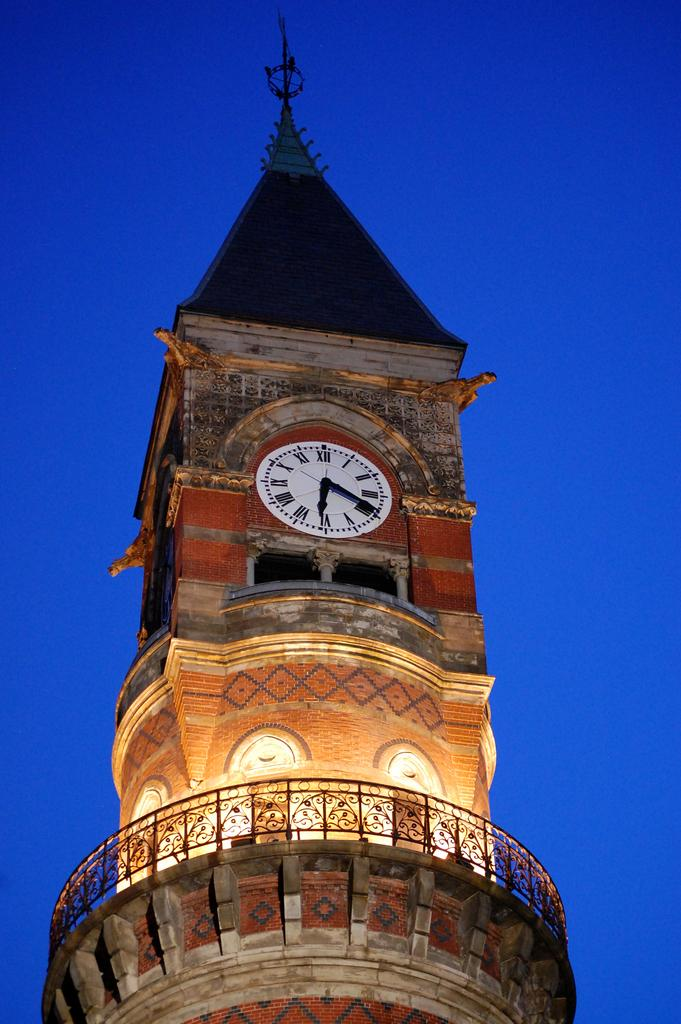What is the main structure in the middle of the image? There is a clock tower in the middle of the image. What can be seen in the background of the image? There is sky visible in the background of the image. What type of lace can be seen on the clock tower in the image? There is no lace present on the clock tower in the image. What type of cemetery is visible in the background of the image? There is no cemetery present in the image; only the clock tower and sky are visible. 